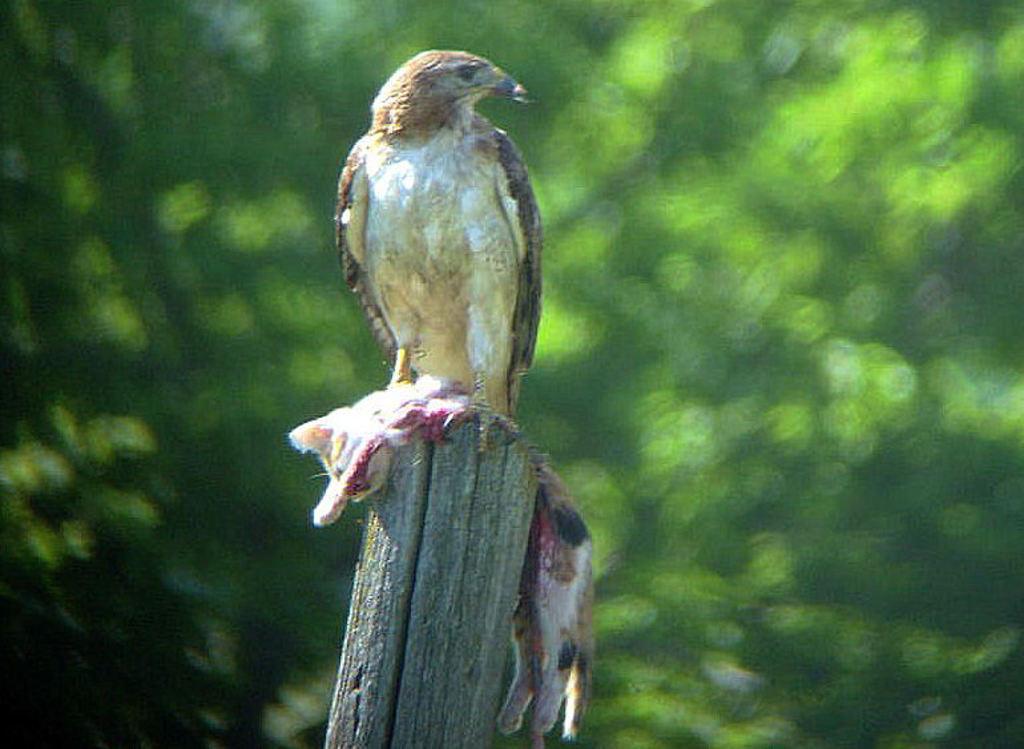Could you give a brief overview of what you see in this image? In the foreground of this image, on a pole, there is a body of a cat and a eagle on it. In the background, there is greenery. 